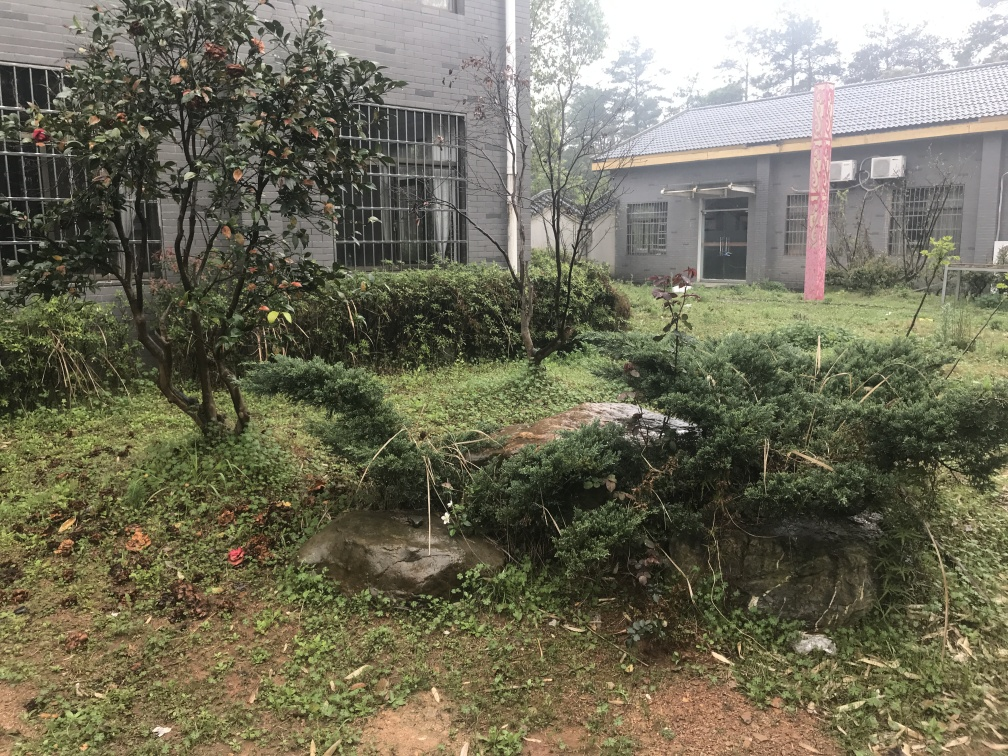Does the image indicate any human activity or intervention? Yes, there are signs of human intervention. The existence of the building, the structured garden layout, and the presence of cut branches suggest recent gardening or cleaning efforts. Although the garden is slightly unkempt, the trimmed bushes and cleared walkways indicate some level of maintenance. 